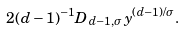<formula> <loc_0><loc_0><loc_500><loc_500>2 ( d - 1 ) ^ { - 1 } D _ { d - 1 , \sigma } y ^ { ( d - 1 ) / \sigma } .</formula> 